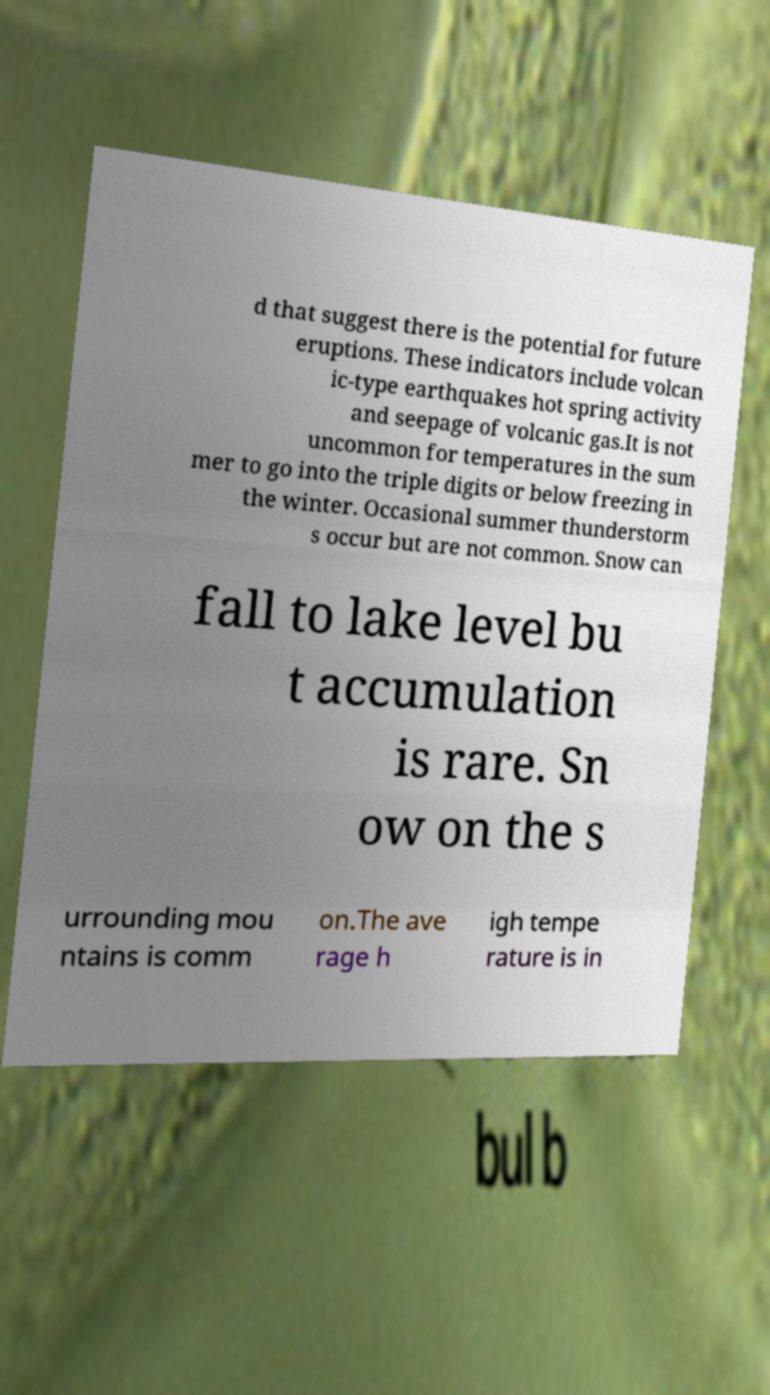Please read and relay the text visible in this image. What does it say? d that suggest there is the potential for future eruptions. These indicators include volcan ic-type earthquakes hot spring activity and seepage of volcanic gas.It is not uncommon for temperatures in the sum mer to go into the triple digits or below freezing in the winter. Occasional summer thunderstorm s occur but are not common. Snow can fall to lake level bu t accumulation is rare. Sn ow on the s urrounding mou ntains is comm on.The ave rage h igh tempe rature is in 